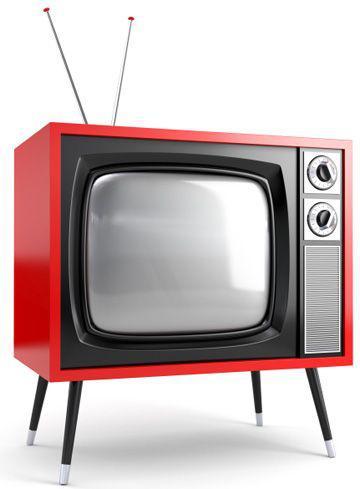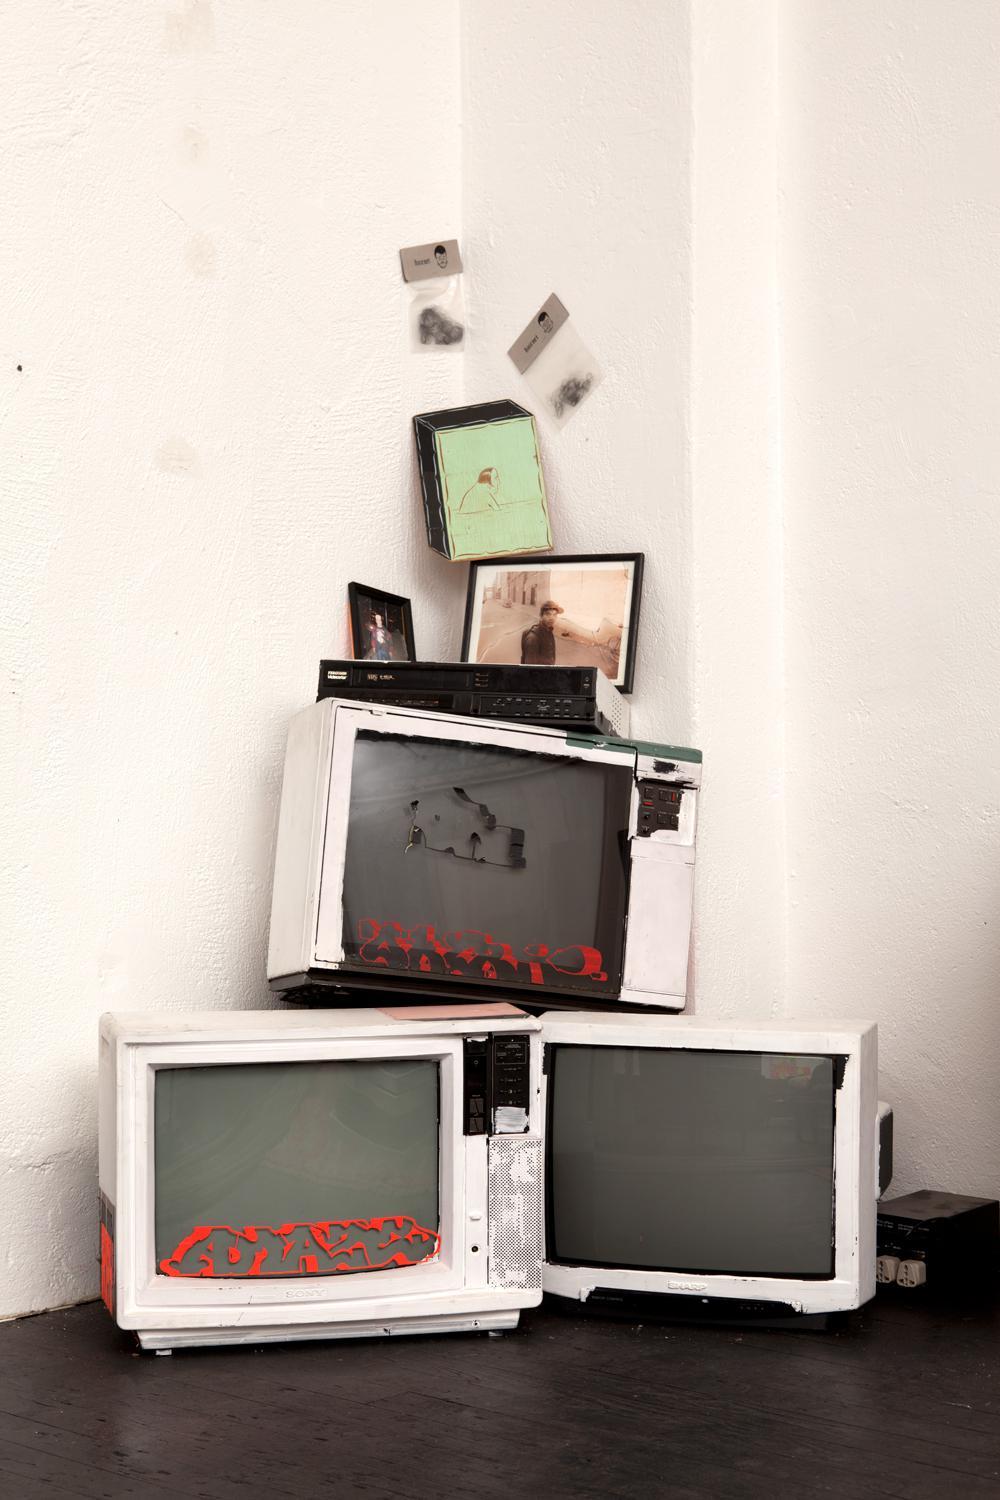The first image is the image on the left, the second image is the image on the right. Analyze the images presented: Is the assertion "Stacked cubes with screens take the shape of an animate object in one image." valid? Answer yes or no. No. The first image is the image on the left, the second image is the image on the right. Given the left and right images, does the statement "A sculpture resembling a lifeform is made from televisions in one of the images." hold true? Answer yes or no. No. 